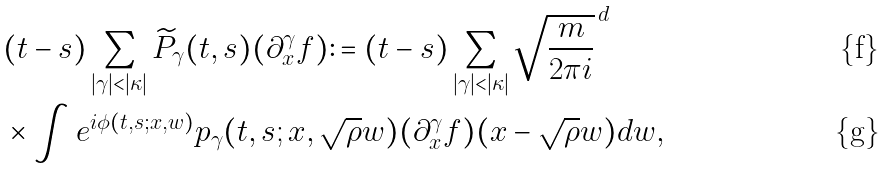<formula> <loc_0><loc_0><loc_500><loc_500>& ( t - s ) \sum _ { | \gamma | < | \kappa | } \widetilde { P } _ { \gamma } ( t , s ) ( \partial _ { x } ^ { \gamma } f ) \colon = ( t - s ) \sum _ { | \gamma | < | \kappa | } \sqrt { \frac { m } { 2 \pi i } } ^ { \, d } \\ & \times \int e ^ { i \phi ( t , s ; x , w ) } p _ { \gamma } ( t , s ; x , \sqrt { \rho } w ) ( \partial _ { x } ^ { \gamma } f ) ( x - \sqrt { \rho } w ) d w ,</formula> 